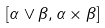Convert formula to latex. <formula><loc_0><loc_0><loc_500><loc_500>[ \alpha \vee \beta , \alpha \times \beta ]</formula> 